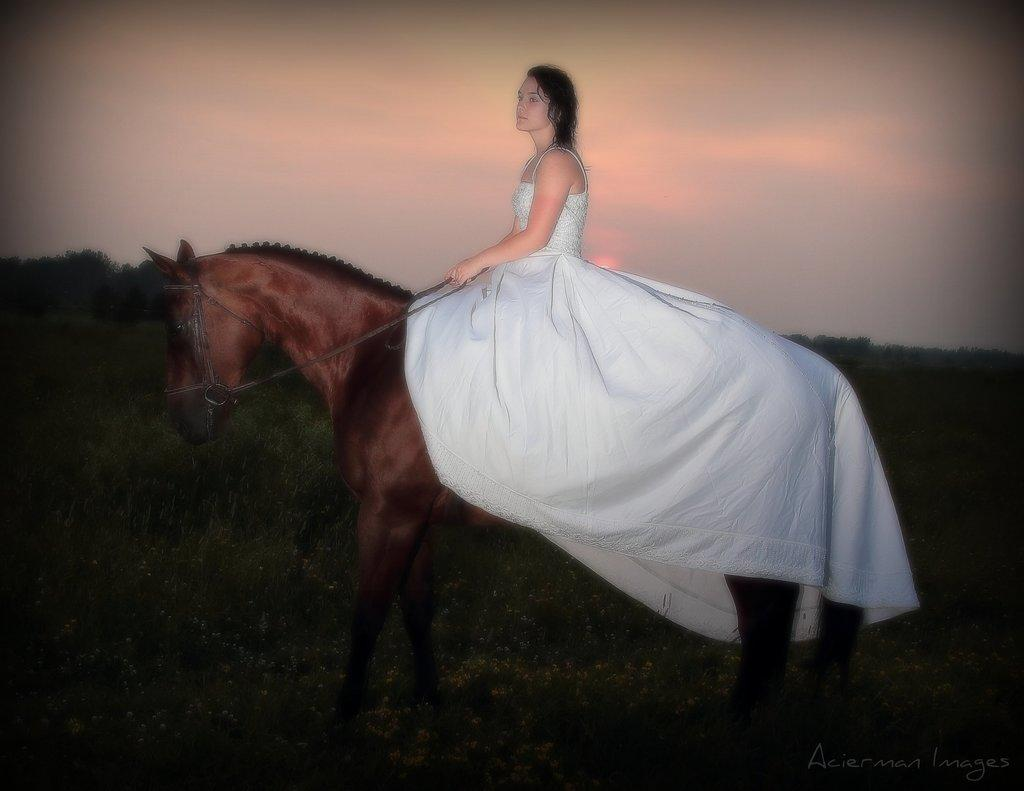Who is the main subject in the image? There is a lady in the image. What is the lady wearing? The lady is wearing a white gown. What is the lady doing in the image? The lady is sitting on a horse. Where is the horse located? The horse is in a grass field. What type of oil can be seen dripping from the cannon in the image? There is no cannon or oil present in the image. What mode of transportation did the lady use for her trip in the image? The lady is sitting on a horse, so no other mode of transportation is mentioned or visible in the image. 